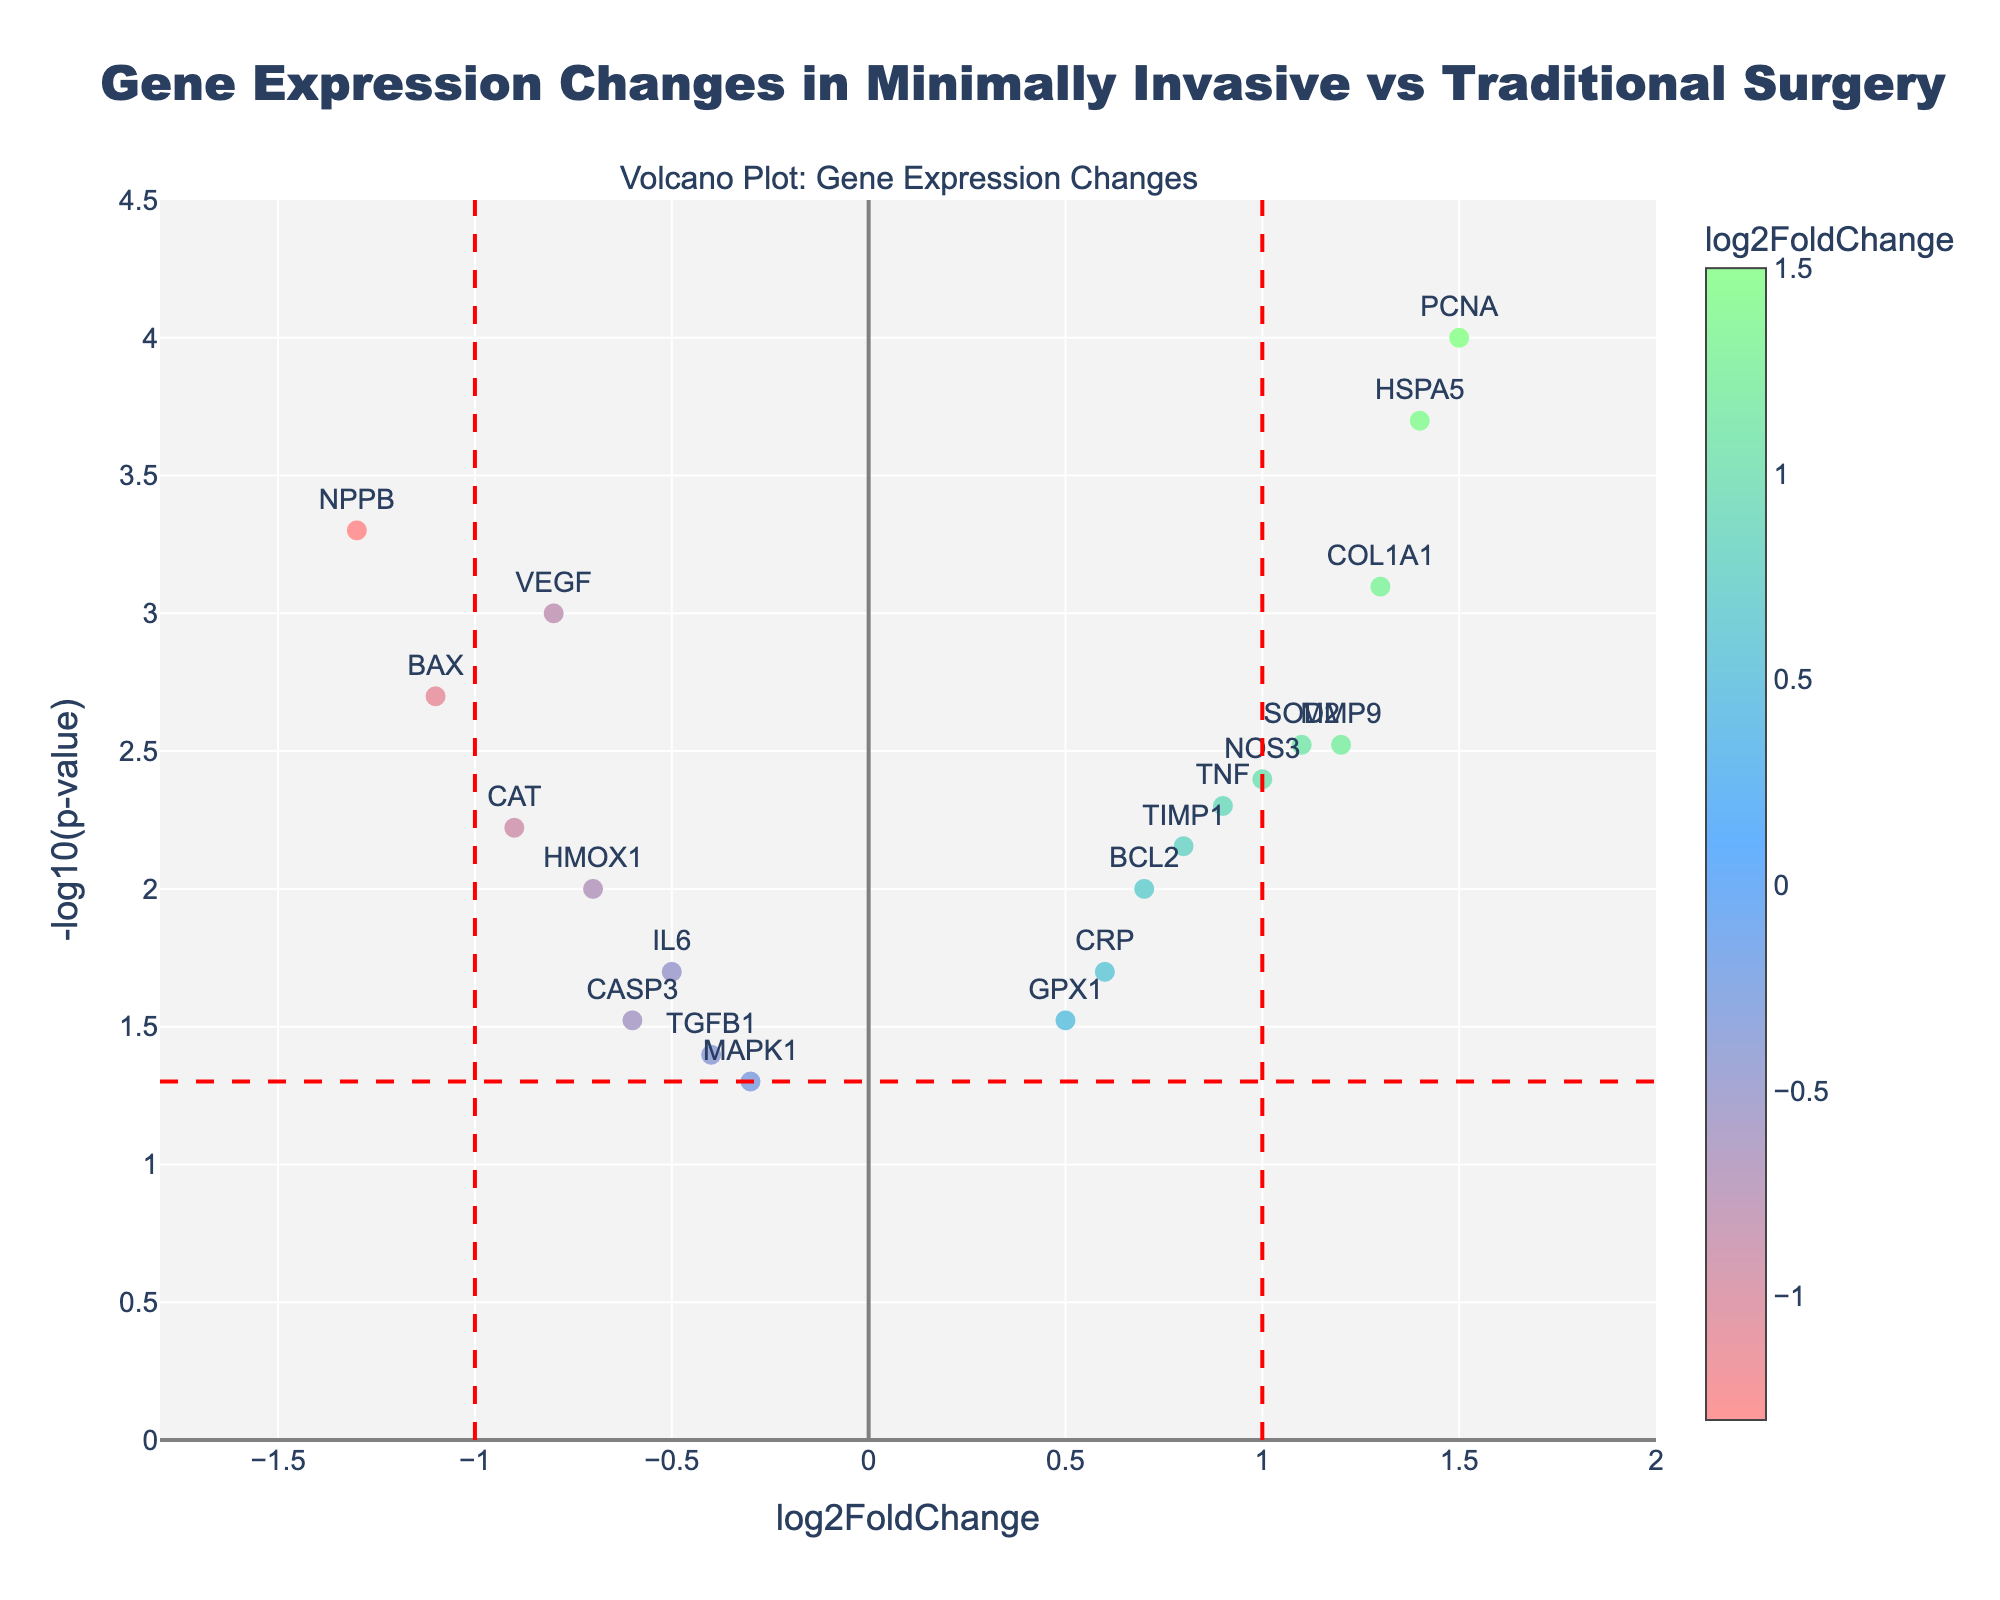What is the title of the volcano plot? The title is usually displayed at the top of the plot. In this case, the title is "Gene Expression Changes in Minimally Invasive vs Traditional Surgery".
Answer: Gene Expression Changes in Minimally Invasive vs Traditional Surgery How many genes have a -log10(p-value) greater than 2? To find this, we look at the y-axis values and count the points above the 2 mark. The genes NOS3, COL1A1, HSPA5, PCNA, and NPPB are the ones with -log10(p-value) greater than 2.
Answer: 5 Which gene has the highest log2FoldChange? By examining the x-axis, the gene with the highest log2FoldChange is the one farthest to the right. This gene is PCNA.
Answer: PCNA How many genes have a log2FoldChange less than -1 and a -log10(p-value) greater than 2? We need to count the points that fulfill both criteria. The gene that meets these conditions is NPPB.
Answer: 1 Which genes fall outside the range of -1 to 1 for log2FoldChange? We look for genes with log2FoldChange values that are either less than -1 or greater than 1. These genes are NPPB, BAX, SOD2, HSPA5, COL1A1, and PCNA.
Answer: NPPB, BAX, SOD2, HSPA5, COL1A1, PCNA What is the y-axis title of the plot? The title of the y-axis is usually indicated next to the axis itself. In this case, it is "-log10(p-value)".
Answer: -log10(p-value) Which gene has the lowest -log10(p-value)? The gene with the lowest -log10(p-value) would be the point closest to the x-axis. This gene is MAPK1.
Answer: MAPK1 What color is used to represent log2FoldChange values close to zero? The color scale usually indicates that log2FoldChange values close to zero are represented by a color around the middle of the scale. Here, this color appears to be blue.
Answer: Blue How does the plot visually indicate the threshold for statistical significance? The plot shows a horizontal red dashed line at -log10(p-value) = 1.3 (which corresponds to a p-value of 0.05), indicating the significance threshold.
Answer: Red dashed line What are the log2FoldChange values for VEGF and HSPA5, and which gene has a more pronounced fold change? VEGF has a log2FoldChange of -0.8, while HSPA5 has a log2FoldChange of 1.4. Comparing absolute values, HSPA5 has a more pronounced fold change.
Answer: HSPA5 